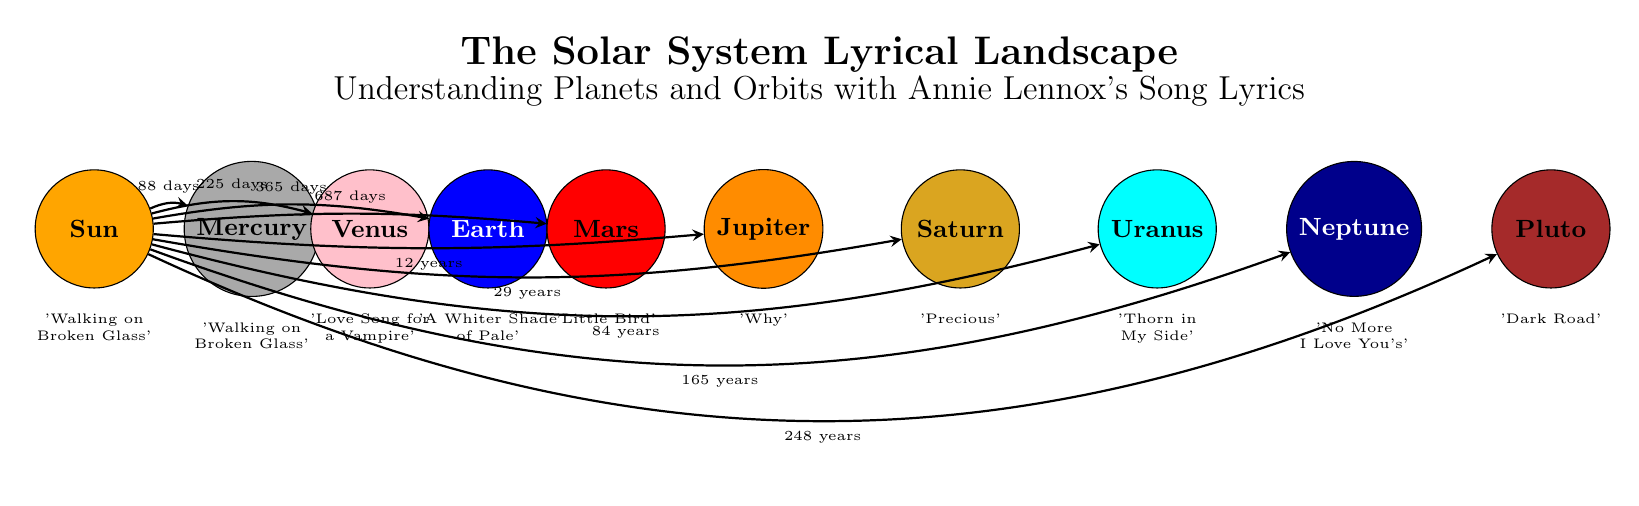What is the orbital period of Jupiter? The diagram indicates that the orbital period of Jupiter, which is labeled next to the arrow pointing towards it, is 12 years.
Answer: 12 years Which planet has the shortest orbital period? By examining the orbits in the diagram, Mercury is the closest to the Sun and is labeled with an orbital period of 88 days, which is shorter than the others.
Answer: 88 days Which song is associated with Earth? Looking at the label below the Earth node, it states 'A Whiter Shade of Pale' as the song associated with Earth.
Answer: A Whiter Shade of Pale How many planets are depicted in the diagram? The diagram shows a total of 9 planets, including the Sun and Pluto, which can be counted directly from the labeled nodes.
Answer: 9 What song is represented by the planet Venus? The label below Venus states 'Love Song for a Vampire', which is the song associated with this planet.
Answer: Love Song for a Vampire Which planet has the longest orbital period? Looking at the labels, Pluto has the longest orbital period listed, which is 248 years. This requires comparing the periods mentioned next to the planets.
Answer: 248 years What is the color of Saturn? The diagram shows the Saturn node filled with a color defined as '218,165,32', which corresponds to a golden shade, as indicated by the Saturn color definition in the code.
Answer: golden Which planet is located furthest from the Sun? The layout of the diagram shows Pluto as the outermost planet, making it the one located furthest from the Sun.
Answer: Pluto Which song is associated with the planet Mars? The label below the Mars node indicates 'Little Bird' as the song linked to this planet.
Answer: Little Bird 